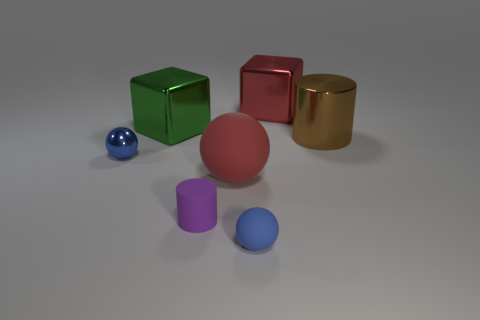What can you infer about the red cube's texture? The red cube has a somewhat matte surface with subtle reflections, suggesting it might have a satin finish. It likely has a smooth touch with very fine texturing that isn't immediately obvious but might be felt upon handling. 